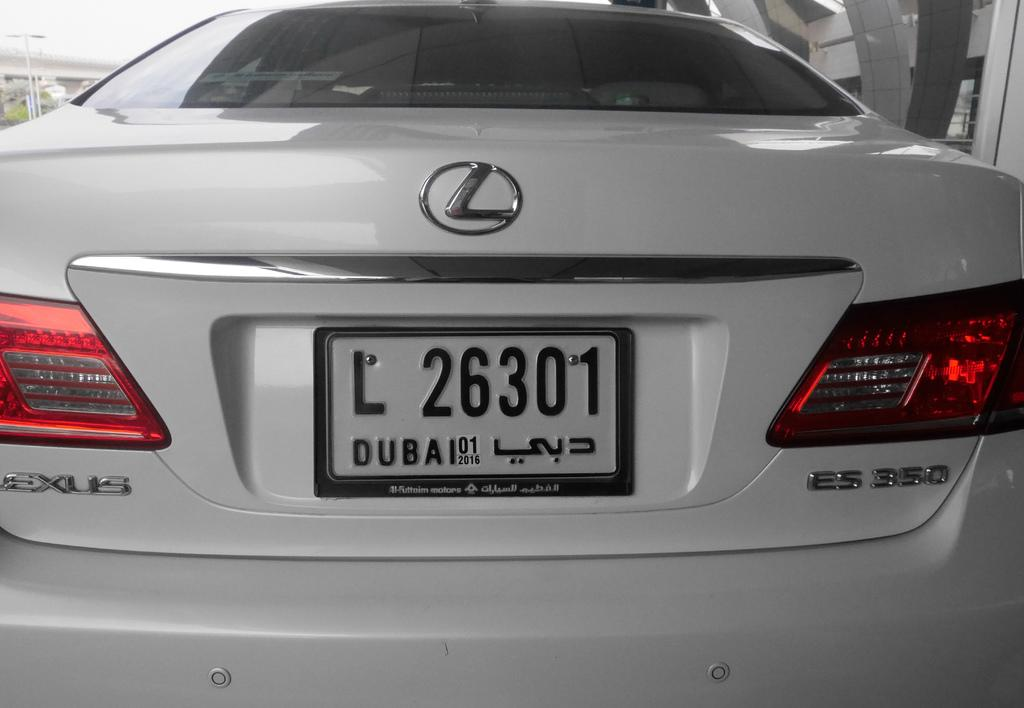<image>
Render a clear and concise summary of the photo. A white car has a license plate displaying L 26301. 